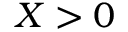<formula> <loc_0><loc_0><loc_500><loc_500>X > 0</formula> 